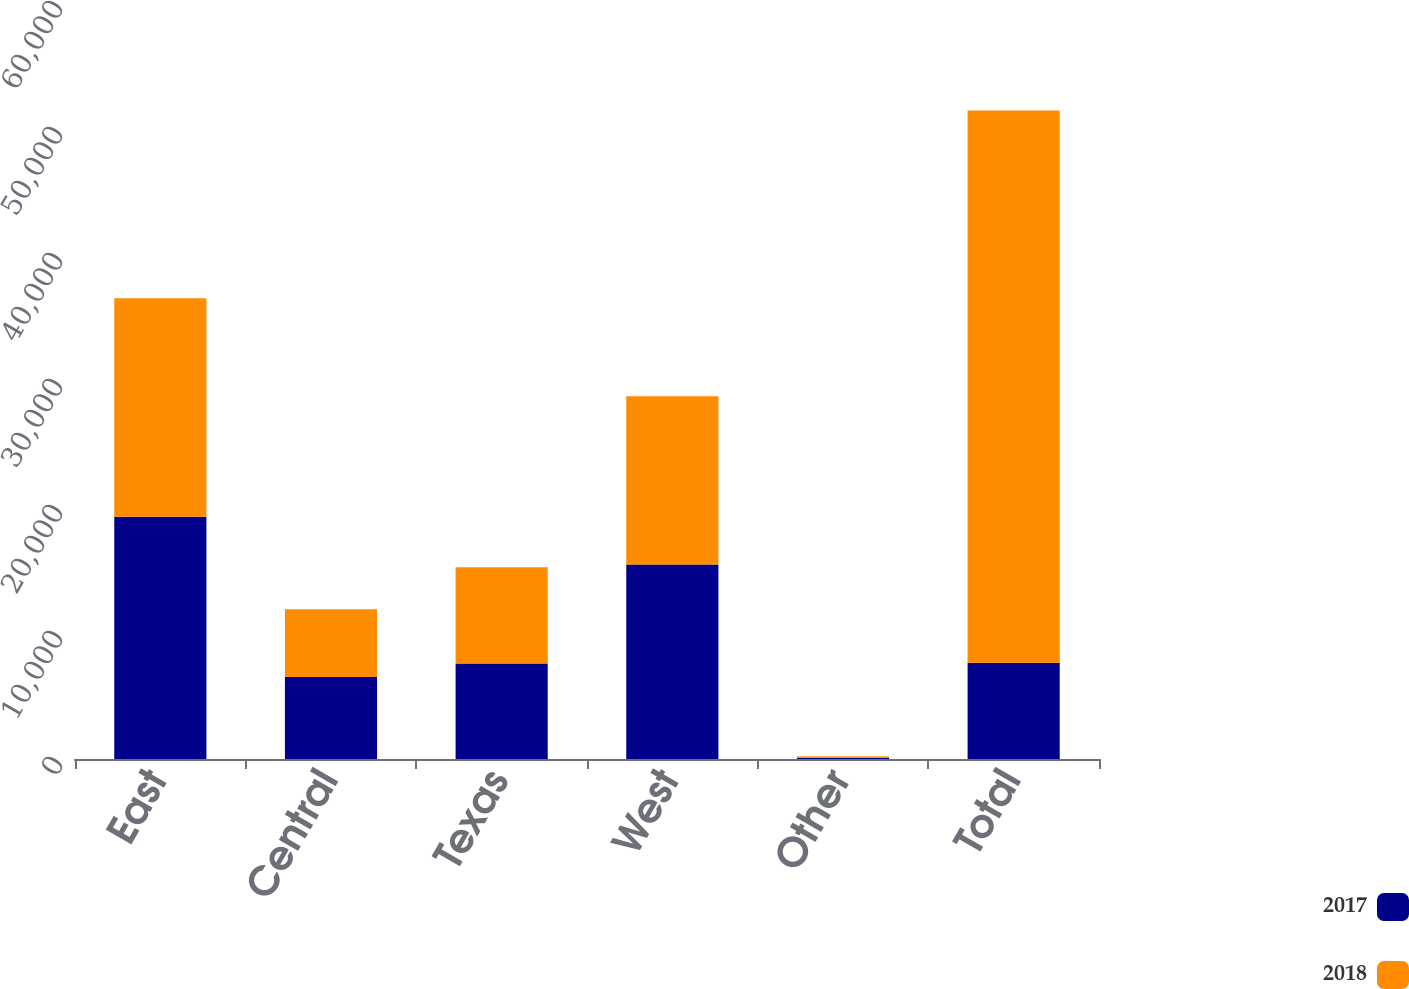Convert chart to OTSL. <chart><loc_0><loc_0><loc_500><loc_500><stacked_bar_chart><ecel><fcel>East<fcel>Central<fcel>Texas<fcel>West<fcel>Other<fcel>Total<nl><fcel>2017<fcel>19231<fcel>6506<fcel>7582<fcel>15434<fcel>103<fcel>7635<nl><fcel>2018<fcel>17339<fcel>5376<fcel>7635<fcel>13355<fcel>123<fcel>43828<nl></chart> 